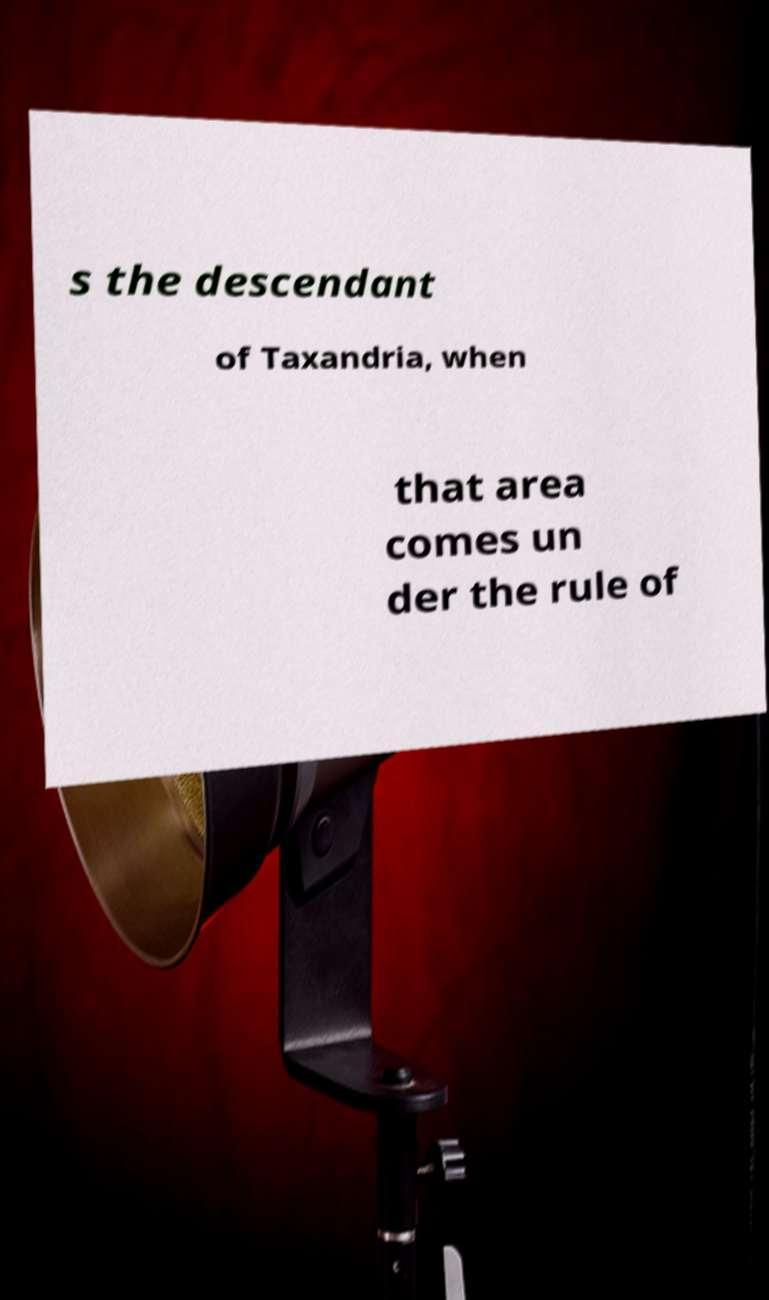Could you extract and type out the text from this image? s the descendant of Taxandria, when that area comes un der the rule of 